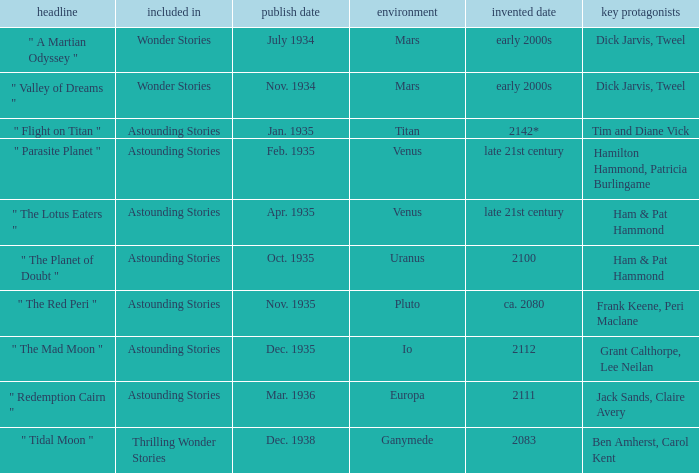Name the title when the main characters are grant calthorpe, lee neilan and the published in of astounding stories " The Mad Moon ". 